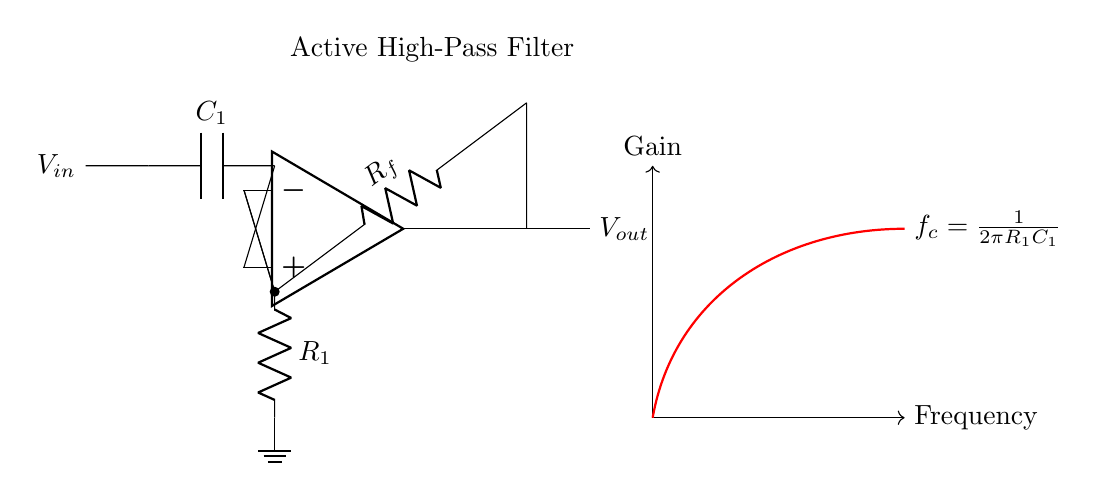What is the input voltage to the circuit? The input voltage is labeled as \(V_{in}\) on the left side of the diagram.
Answer: \(V_{in}\) What type of filter is represented by the circuit? The circuit is labeled as an "Active High-Pass Filter," indicating its function in allowing high frequencies to pass while attenuating low frequencies.
Answer: Active High-Pass Filter What are the values of the components \(C_1\) and \(R_f\)? The diagram does not specify numerical values for \(C_1\) and \(R_f\), as they represent a capacitor and resistor, respectively, without numerical designations in the provided circuit.
Answer: Not specified What is the formula used to calculate the cutoff frequency? The cutoff frequency \(f_c\) is defined in the diagram as \(f_c = \frac{1}{2\pi R_1C_1}\), which indicates the frequency at which the output power drops to half its value.
Answer: \(f_c = \frac{1}{2\pi R_1C_1}\) Where does the feedback loop connect in the circuit? The feedback loop connects from the negative input of the op-amp to the junction between \(R_f\) and the output. This indicates the configuration for the amplifier to maintain stability and desired gain.
Answer: Negative input to feedback resistor What is the role of \(R_1\) in the circuit? The resistor \(R_1\) is connected to the ground and plays a critical role in establishing the cutoff frequency along with capacitor \(C_1\), affecting the filter's response to frequencies.
Answer: Establishes cutoff frequency What does the direction of the red gain line indicate? The direction of the red gain line, sloping upwards as frequency increases, indicates that the output gain increases for higher frequencies and shows typical behavior for a high-pass filter.
Answer: Output gain increases with frequency 